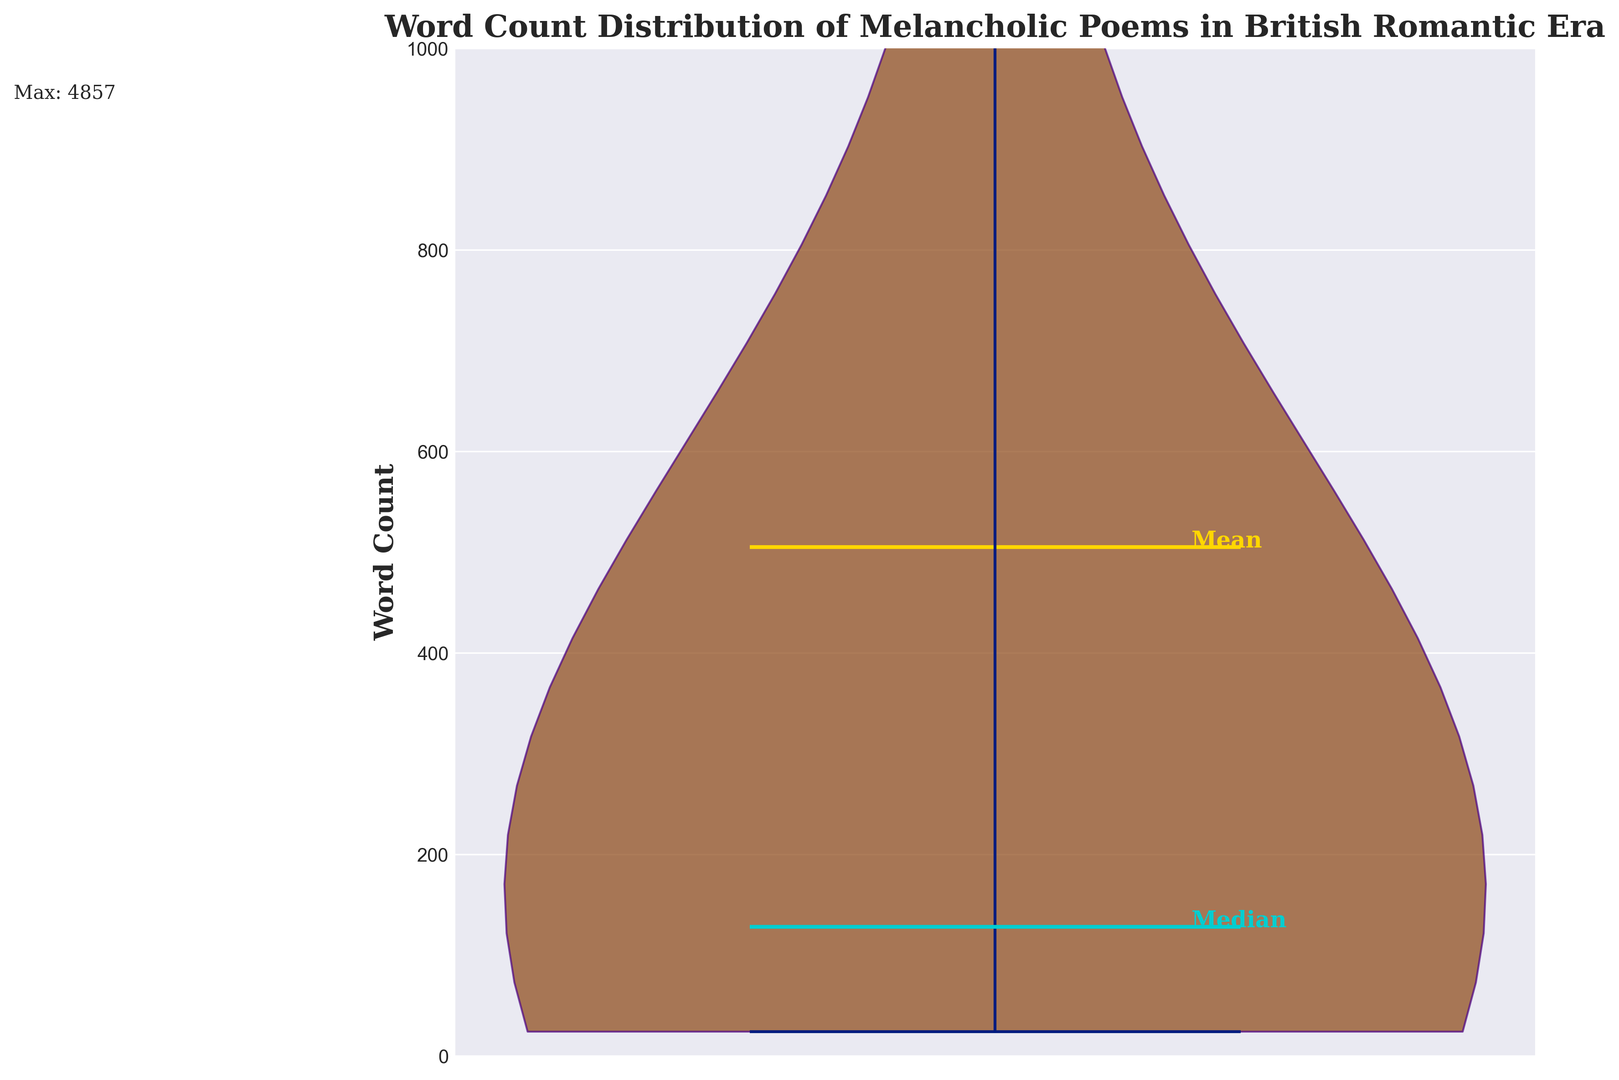what is the median word count of melancholic poems in the British Romantic era? The violin plot shows a horizontal line at the position of the median. In the plot, the median is indicated visually by the cyan horizontal line labelled "Median" at around 112 words.
Answer: 112 what is the mean word count of the melancholic poems? The violin plot includes a golden horizontal line representing the mean. In the plot, the mean is indicated visually by the golden horizontal line labelled "Mean" above the median line, at around 277 words.
Answer: 277 what is the maximum word count of the melancholic poems? The maximum word count is indicated by a text annotation at the top edge of the plot that says "Max: 4857." This refers to the poem "The Rime of the Ancient Mariner," which is also connected via an arrow annotation.
Answer: 4857 what is the range of word counts in the plot if we focus on the main distribution below 1000 words? The y-axis range is set from 0 to 1000 words, as per the plot's scale, focusing on the majority of the data, excluding "The Rime of the Ancient Mariner". The minimum word count is visually nearly zero (with the shortest bars indicating just above 20), while the maximum within this range is around 700, as seen at the top end of the main violin shape distribution.
Answer: 680 how does the word count of “Elegy Written in a Country Churchyard” compare to “Ode to a Nightingale”? The word counts for the specific poems aren't visually indicated directly, but the distribution shows that most poems have a count below 512 words; "Elegy Written in a Country Churchyard" at 512 words is likely higher than “Ode to a Nightingale” at 280 words. Comparing 512 and 280: 512 is greater.
Answer: 512 is greater what does the color and width of the violin plot indicate about the distribution of word counts? The color and width of the violin plot indicate density. The brownish coloring indicates areas of higher density while the width of the section reflects how many poems fall within that range of word counts. Wider sections signify higher density within the main distribution that peaks around 100 to 150 words.
Answer: Density of data points within ranges how does the proportion of poems with word counts below 200 compare with those above it? Visually, the majority of the violin plot's area and the data distribution appear below the 200-word mark, indicating a higher density of poems with word counts below 200. This is reinforced by the median being 112 and the mean slightly above it, suggesting most poems have relatively fewer words.
Answer: More poems have word counts below 200 